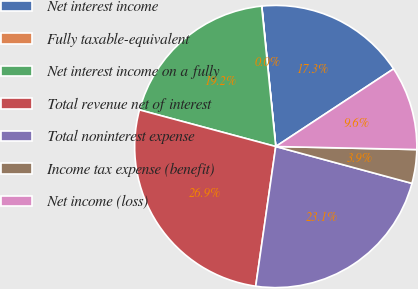Convert chart to OTSL. <chart><loc_0><loc_0><loc_500><loc_500><pie_chart><fcel>Net interest income<fcel>Fully taxable-equivalent<fcel>Net interest income on a fully<fcel>Total revenue net of interest<fcel>Total noninterest expense<fcel>Income tax expense (benefit)<fcel>Net income (loss)<nl><fcel>17.3%<fcel>0.02%<fcel>19.22%<fcel>26.91%<fcel>23.06%<fcel>3.86%<fcel>9.62%<nl></chart> 